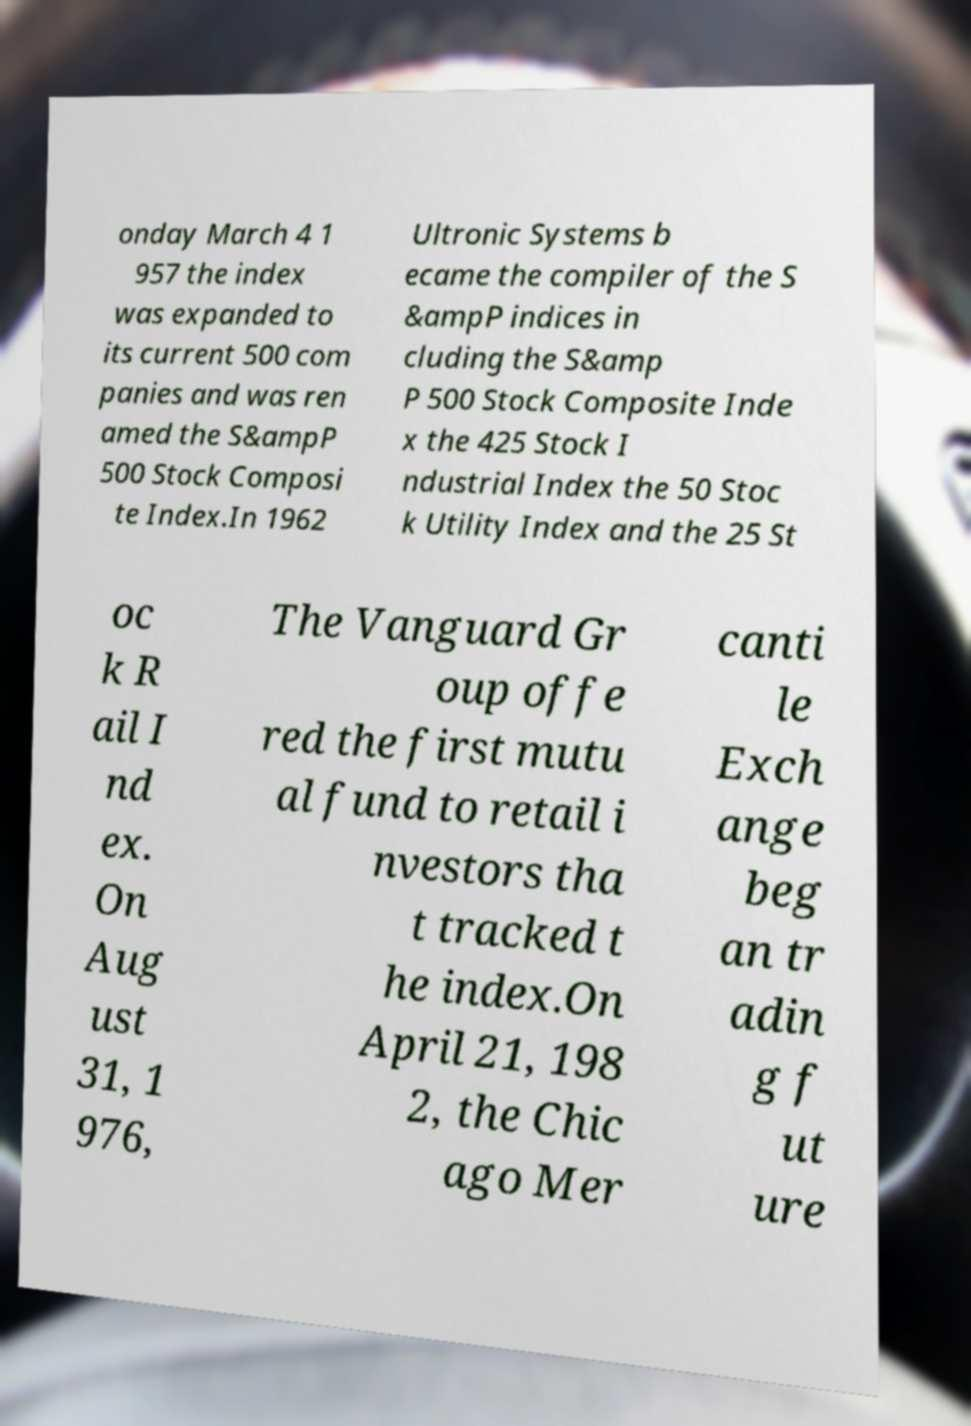Please identify and transcribe the text found in this image. onday March 4 1 957 the index was expanded to its current 500 com panies and was ren amed the S&ampP 500 Stock Composi te Index.In 1962 Ultronic Systems b ecame the compiler of the S &ampP indices in cluding the S&amp P 500 Stock Composite Inde x the 425 Stock I ndustrial Index the 50 Stoc k Utility Index and the 25 St oc k R ail I nd ex. On Aug ust 31, 1 976, The Vanguard Gr oup offe red the first mutu al fund to retail i nvestors tha t tracked t he index.On April 21, 198 2, the Chic ago Mer canti le Exch ange beg an tr adin g f ut ure 